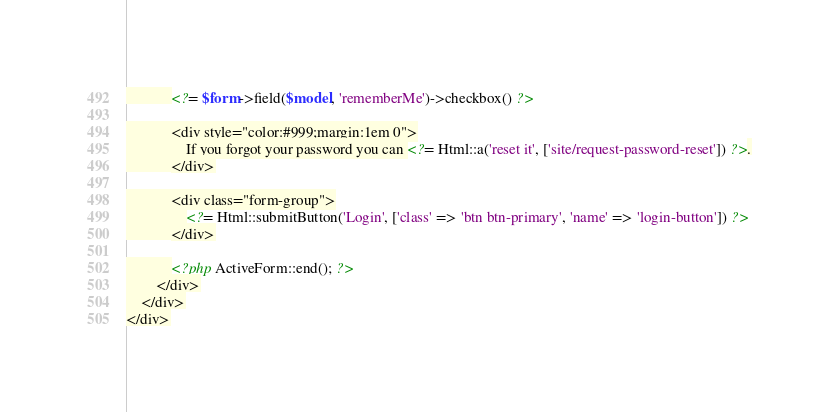<code> <loc_0><loc_0><loc_500><loc_500><_PHP_>            <?= $form->field($model, 'rememberMe')->checkbox() ?>

            <div style="color:#999;margin:1em 0">
                If you forgot your password you can <?= Html::a('reset it', ['site/request-password-reset']) ?>.
            </div>

            <div class="form-group">
                <?= Html::submitButton('Login', ['class' => 'btn btn-primary', 'name' => 'login-button']) ?>
            </div>

            <?php ActiveForm::end(); ?>
        </div>
    </div>
</div>
</code> 